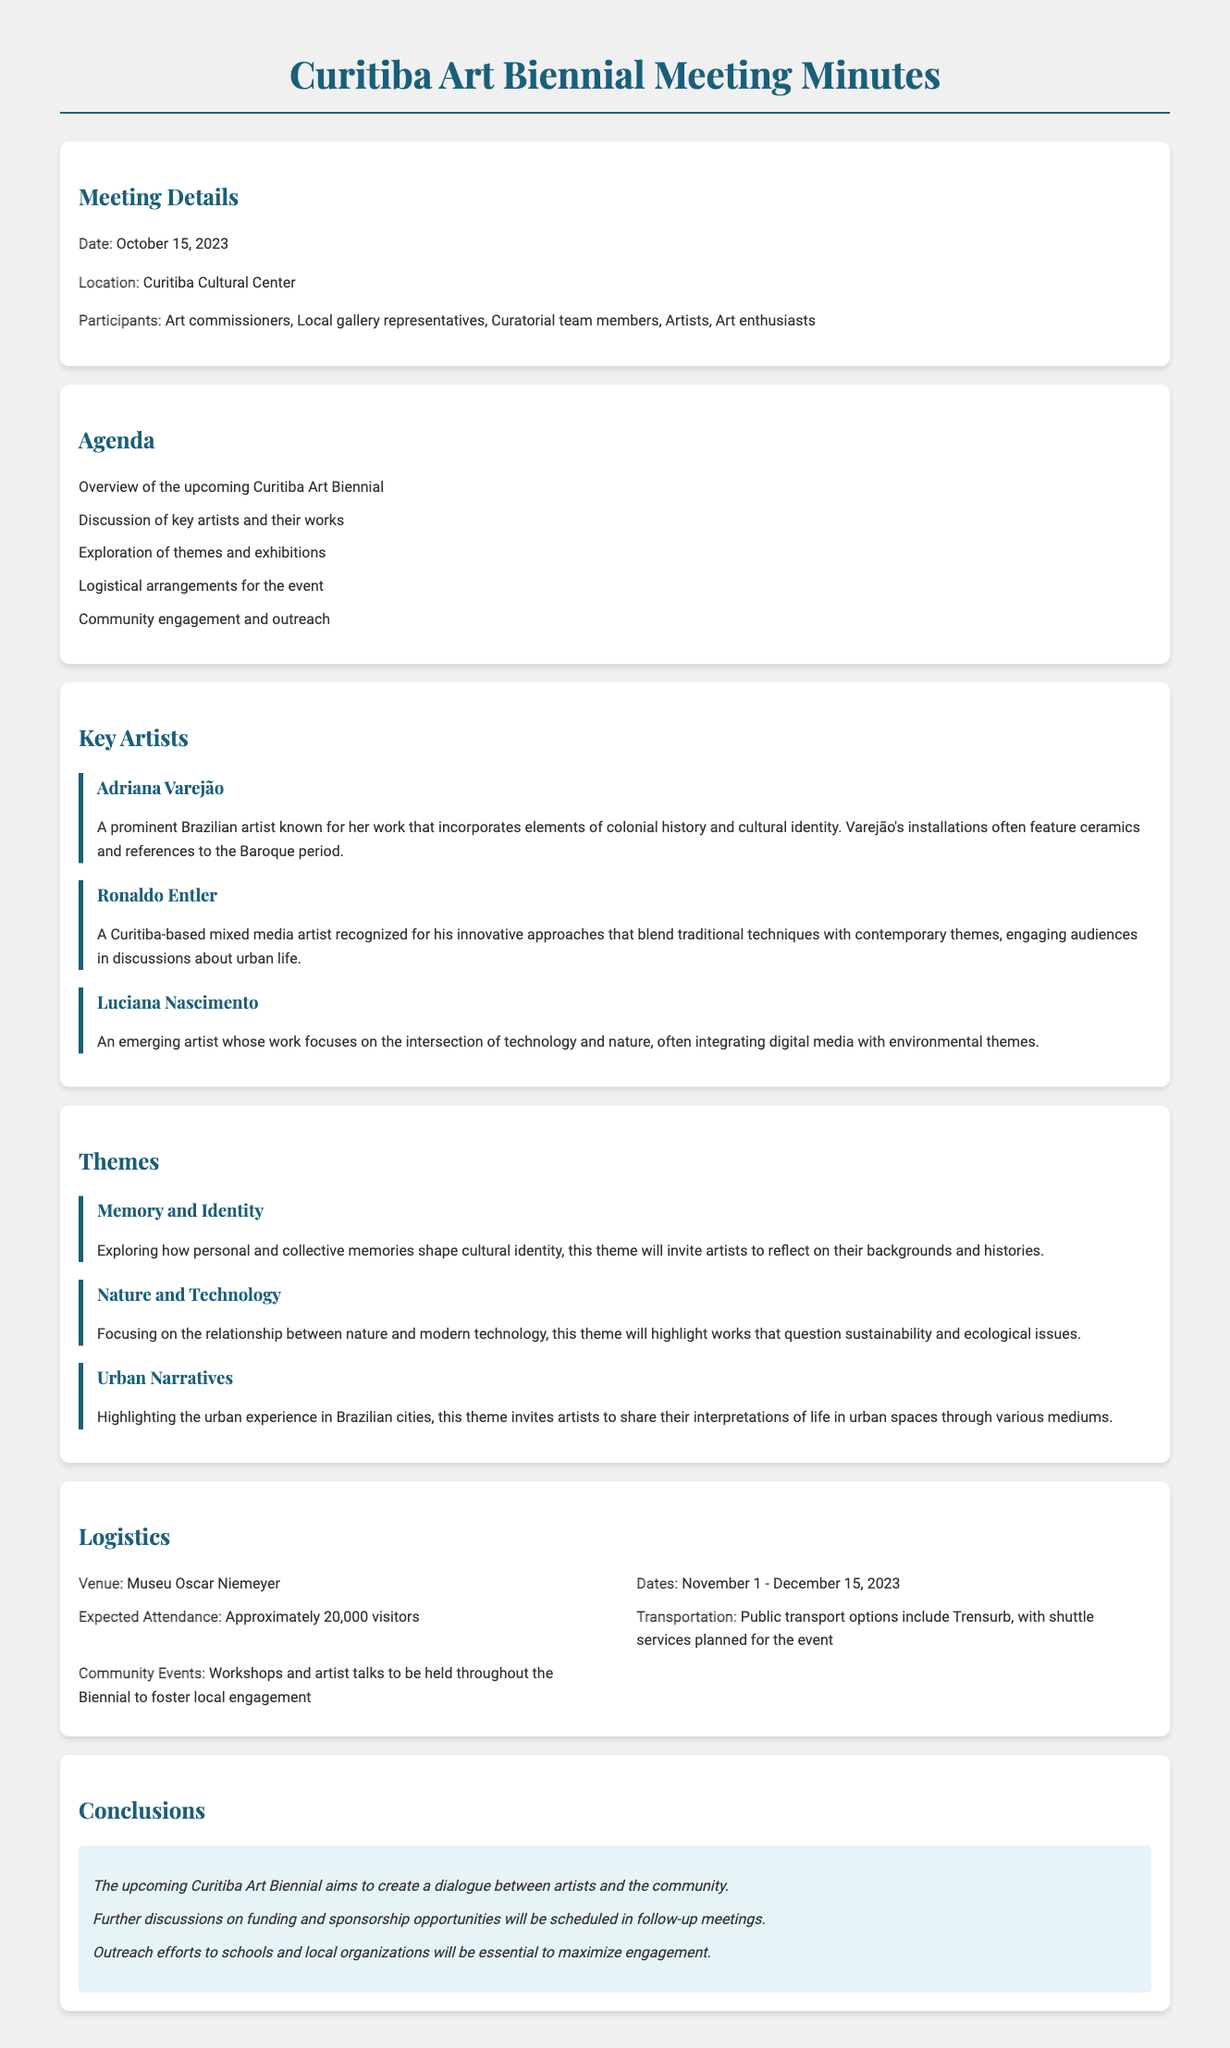What is the date of the meeting? The date of the meeting is explicitly stated in the document as October 15, 2023.
Answer: October 15, 2023 Who is a prominent Brazilian artist mentioned? The document lists Adriana Varejão as a prominent Brazilian artist known for her specific style and themes.
Answer: Adriana Varejão What is the expected attendance for the event? The document specifies that the expected attendance is approximately 20,000 visitors.
Answer: Approximately 20,000 visitors What theme addresses the relationship between nature and modern technology? The theme "Nature and Technology" focuses on this relationship, as described in the document.
Answer: Nature and Technology Where will the Curitiba Art Biennial take place? The venue for the Biennial is mentioned as Museu Oscar Niemeyer in the document.
Answer: Museu Oscar Niemeyer What aspect will community events emphasize during the Biennial? The community events will focus on workshops and artist talks, which are intended to foster local engagement.
Answer: Workshops and artist talks Which theme invites artists to share their interpretations of urban life? The "Urban Narratives" theme is aimed specifically at this form of artistic expression.
Answer: Urban Narratives What is the concluding statement regarding outreach efforts? The document concludes that outreach efforts to schools and local organizations are essential for maximizing engagement.
Answer: Essential to maximize engagement 